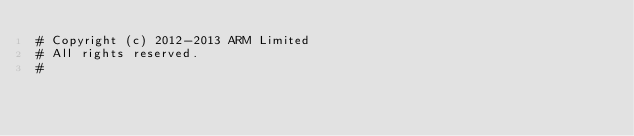Convert code to text. <code><loc_0><loc_0><loc_500><loc_500><_Python_># Copyright (c) 2012-2013 ARM Limited
# All rights reserved.
#</code> 